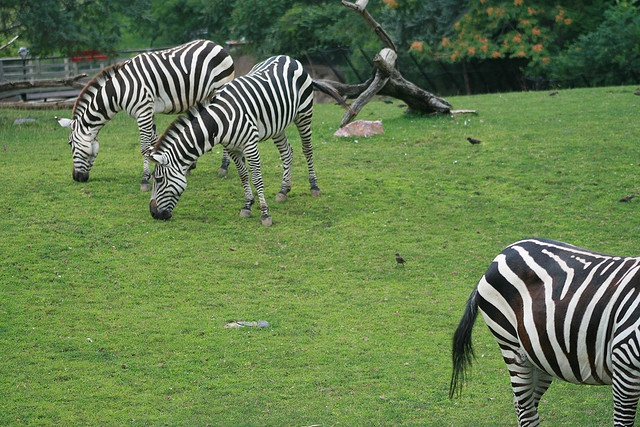Describe the objects in this image and their specific colors. I can see zebra in black, gray, lightgray, and darkgray tones, zebra in black, gray, lightgray, and darkgray tones, zebra in black, lightgray, gray, and darkgray tones, bird in black, lightgray, darkgray, and gray tones, and bird in black, darkgray, olive, and gray tones in this image. 